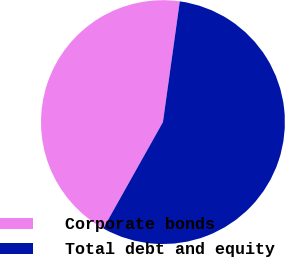Convert chart. <chart><loc_0><loc_0><loc_500><loc_500><pie_chart><fcel>Corporate bonds<fcel>Total debt and equity<nl><fcel>44.07%<fcel>55.93%<nl></chart> 